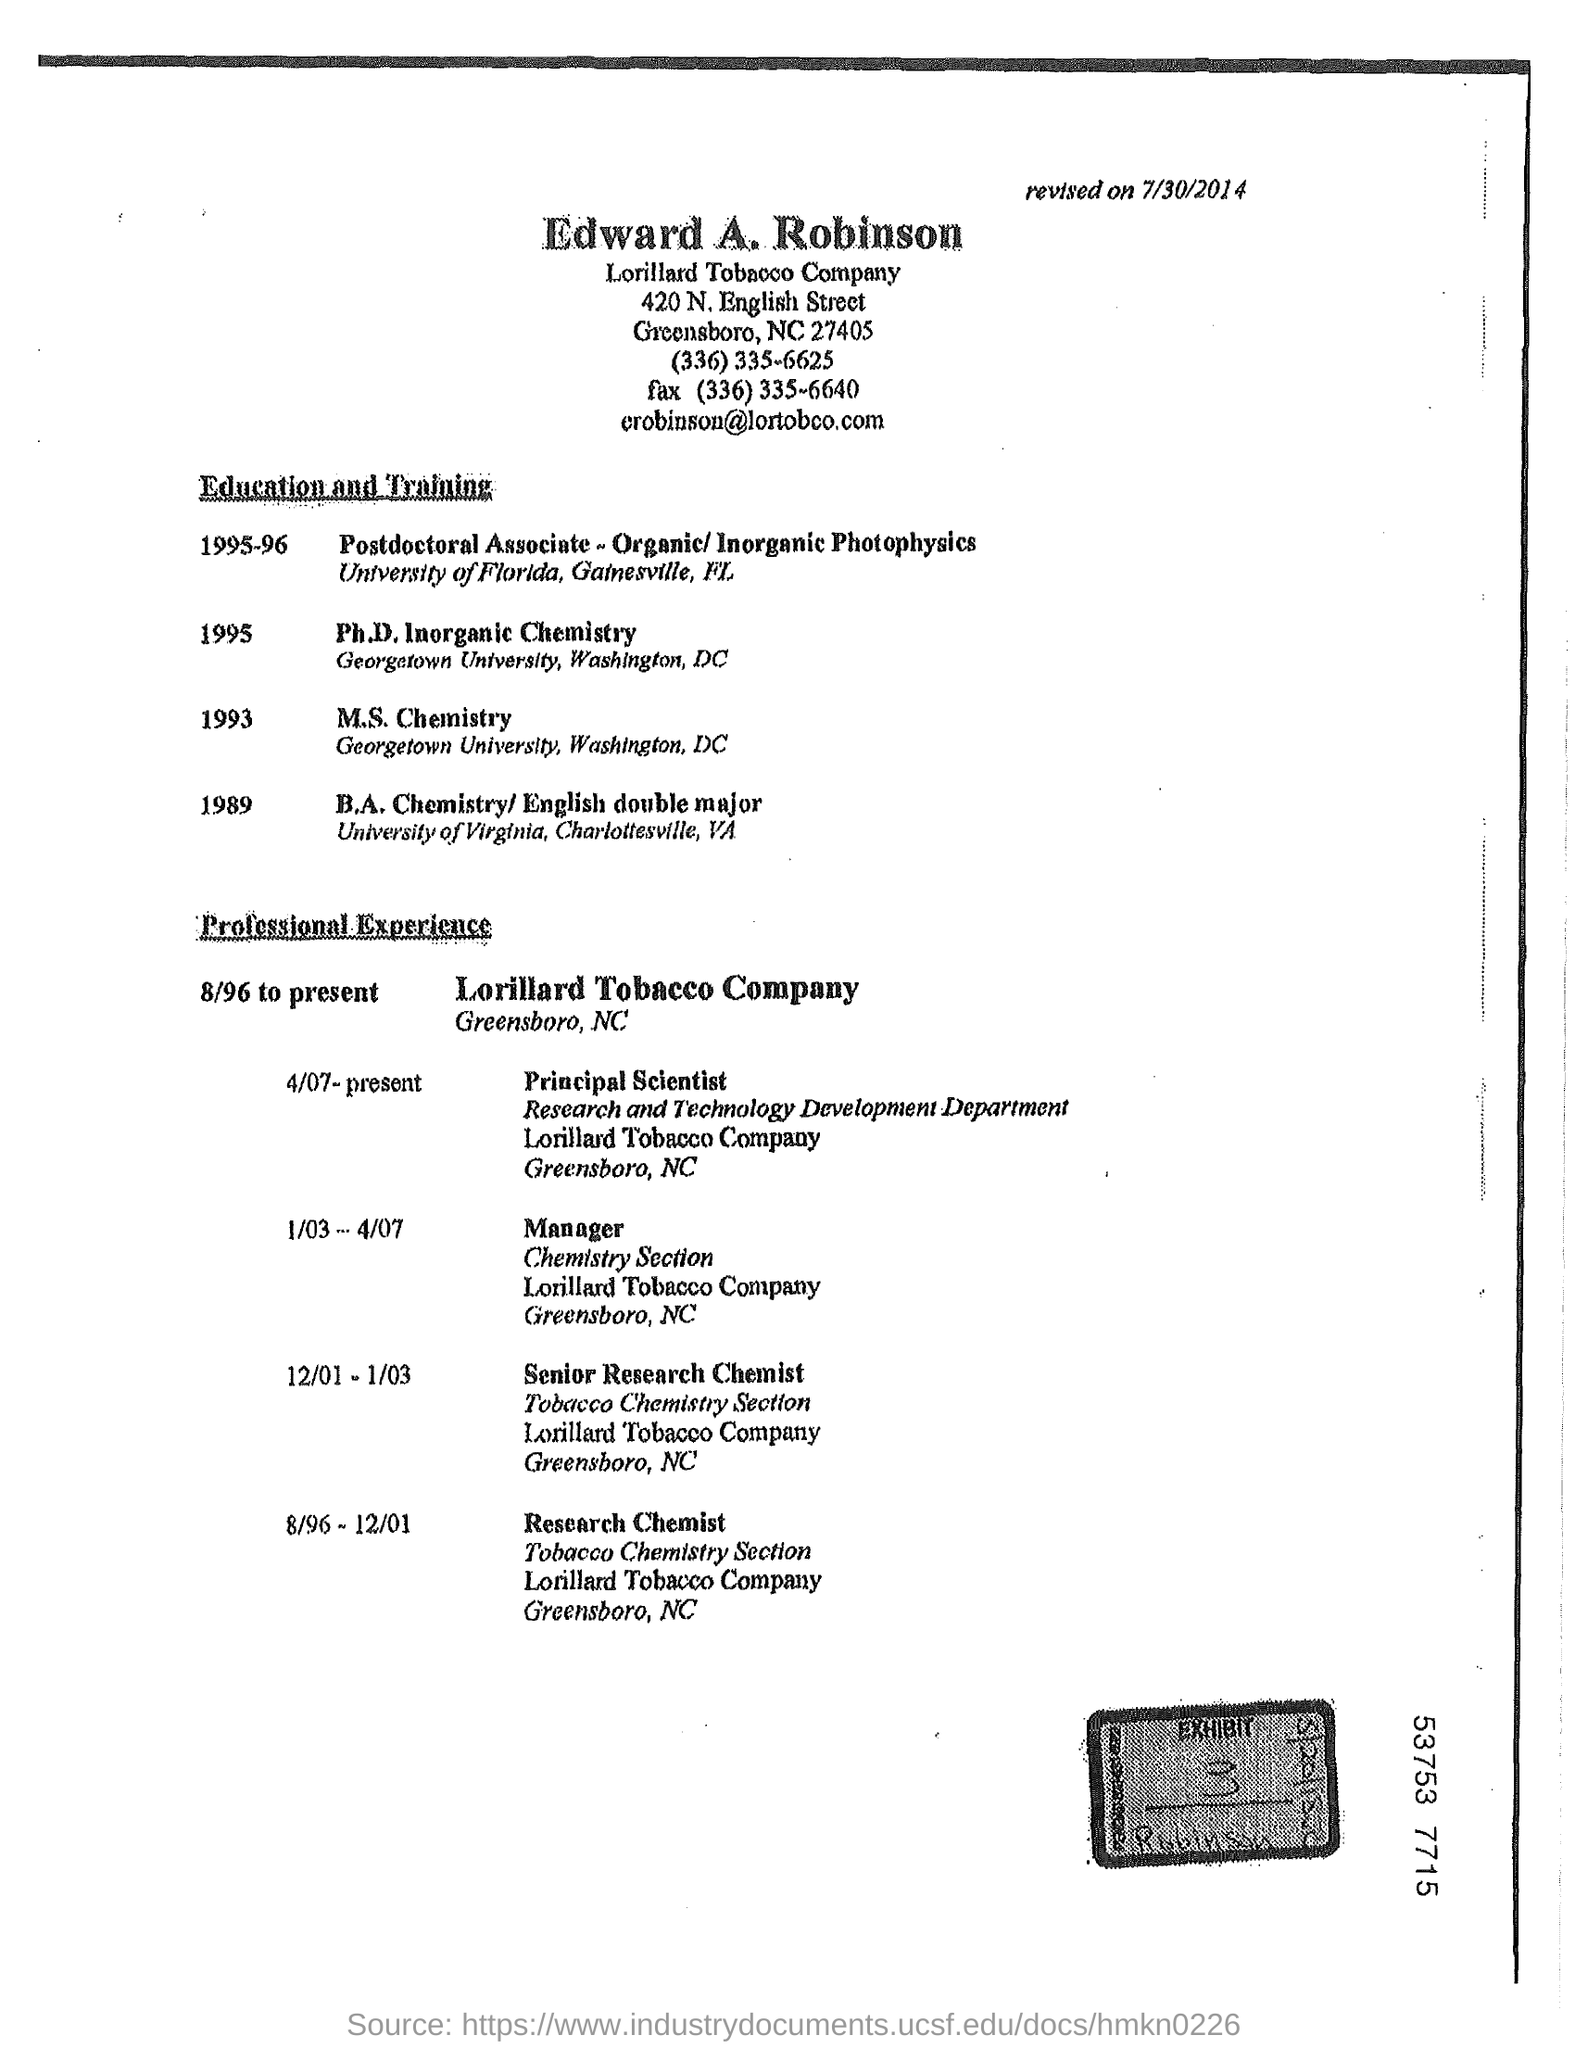Point out several critical features in this image. The fax is (336) 335-6640. 